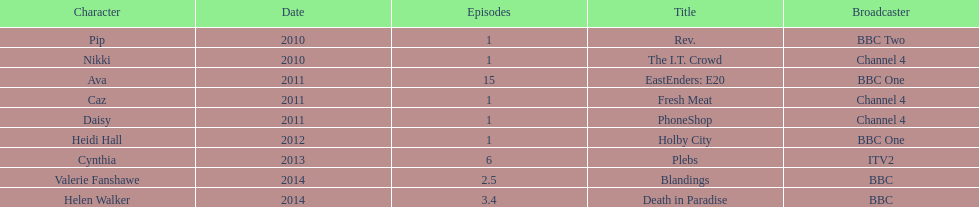Can you give me this table as a dict? {'header': ['Character', 'Date', 'Episodes', 'Title', 'Broadcaster'], 'rows': [['Pip', '2010', '1', 'Rev.', 'BBC Two'], ['Nikki', '2010', '1', 'The I.T. Crowd', 'Channel 4'], ['Ava', '2011', '15', 'EastEnders: E20', 'BBC One'], ['Caz', '2011', '1', 'Fresh Meat', 'Channel 4'], ['Daisy', '2011', '1', 'PhoneShop', 'Channel 4'], ['Heidi Hall', '2012', '1', 'Holby City', 'BBC One'], ['Cynthia', '2013', '6', 'Plebs', 'ITV2'], ['Valerie Fanshawe', '2014', '2.5', 'Blandings', 'BBC'], ['Helen Walker', '2014', '3.4', 'Death in Paradise', 'BBC']]} How many television credits does this actress have? 9. 